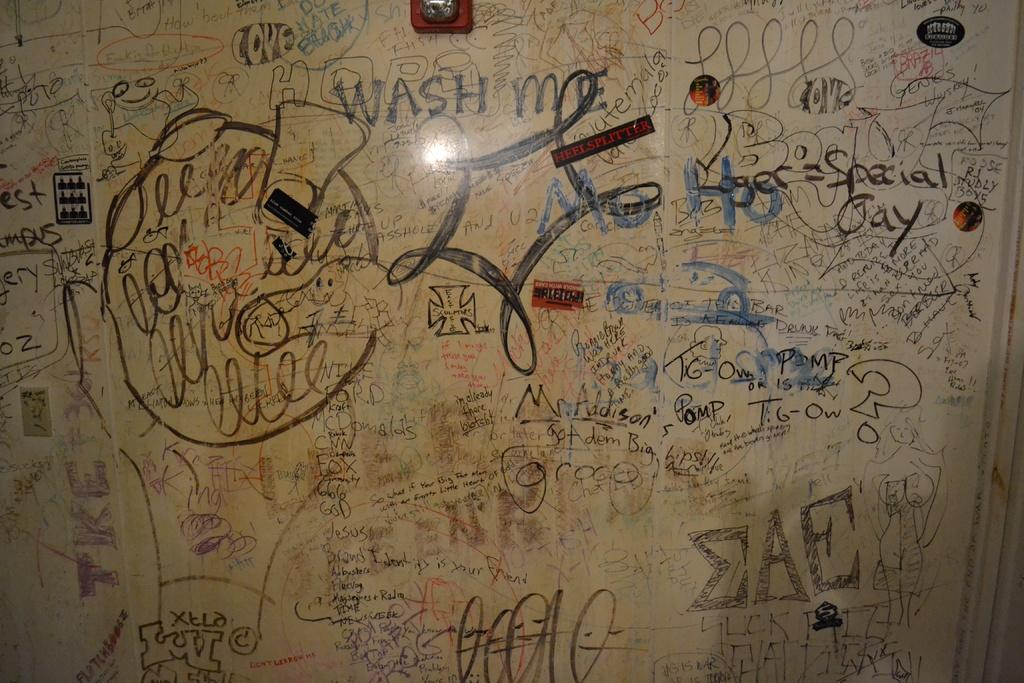<image>
Render a clear and concise summary of the photo. A white board is covered with a lot of writing, including the phrase "wash me" on the top. 